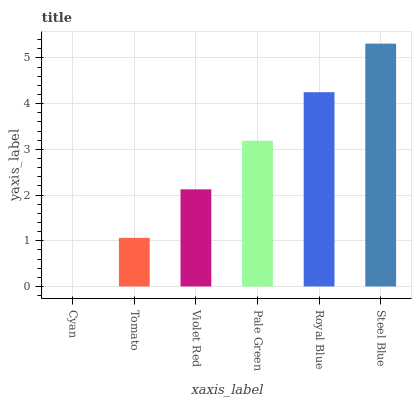Is Cyan the minimum?
Answer yes or no. Yes. Is Steel Blue the maximum?
Answer yes or no. Yes. Is Tomato the minimum?
Answer yes or no. No. Is Tomato the maximum?
Answer yes or no. No. Is Tomato greater than Cyan?
Answer yes or no. Yes. Is Cyan less than Tomato?
Answer yes or no. Yes. Is Cyan greater than Tomato?
Answer yes or no. No. Is Tomato less than Cyan?
Answer yes or no. No. Is Pale Green the high median?
Answer yes or no. Yes. Is Violet Red the low median?
Answer yes or no. Yes. Is Cyan the high median?
Answer yes or no. No. Is Pale Green the low median?
Answer yes or no. No. 